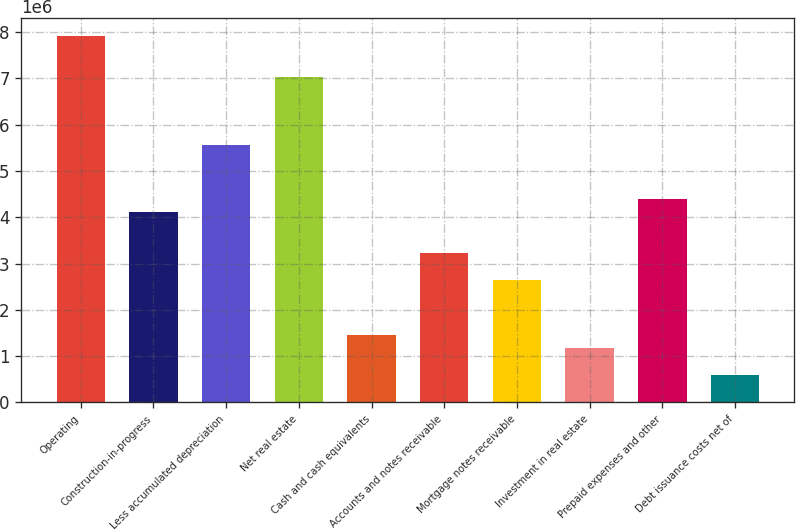Convert chart. <chart><loc_0><loc_0><loc_500><loc_500><bar_chart><fcel>Operating<fcel>Construction-in-progress<fcel>Less accumulated depreciation<fcel>Net real estate<fcel>Cash and cash equivalents<fcel>Accounts and notes receivable<fcel>Mortgage notes receivable<fcel>Investment in real estate<fcel>Prepaid expenses and other<fcel>Debt issuance costs net of<nl><fcel>7.91379e+06<fcel>4.10372e+06<fcel>5.56913e+06<fcel>7.03454e+06<fcel>1.46598e+06<fcel>3.22447e+06<fcel>2.63831e+06<fcel>1.1729e+06<fcel>4.3968e+06<fcel>586733<nl></chart> 